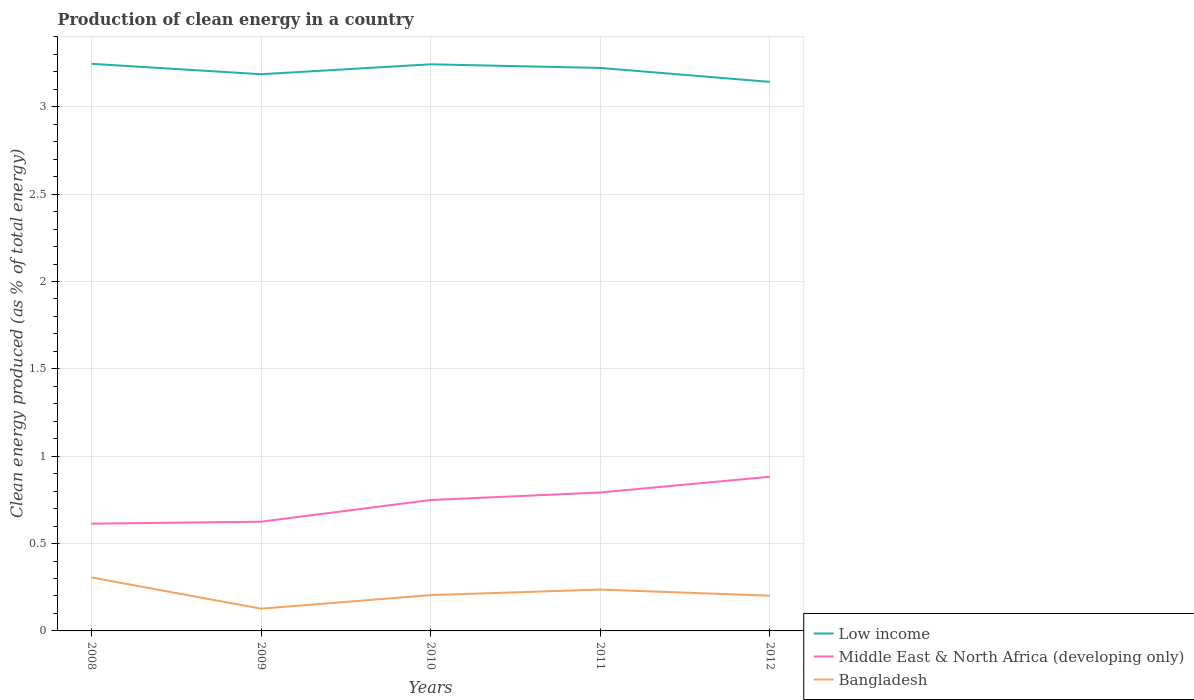Does the line corresponding to Bangladesh intersect with the line corresponding to Low income?
Offer a terse response. No. Is the number of lines equal to the number of legend labels?
Ensure brevity in your answer.  Yes. Across all years, what is the maximum percentage of clean energy produced in Bangladesh?
Your answer should be very brief. 0.13. What is the total percentage of clean energy produced in Bangladesh in the graph?
Your response must be concise. 0.1. What is the difference between the highest and the second highest percentage of clean energy produced in Middle East & North Africa (developing only)?
Your response must be concise. 0.27. What is the difference between the highest and the lowest percentage of clean energy produced in Bangladesh?
Offer a very short reply. 2. What is the difference between two consecutive major ticks on the Y-axis?
Offer a terse response. 0.5. Are the values on the major ticks of Y-axis written in scientific E-notation?
Provide a short and direct response. No. Does the graph contain grids?
Give a very brief answer. Yes. Where does the legend appear in the graph?
Keep it short and to the point. Bottom right. How many legend labels are there?
Provide a succinct answer. 3. How are the legend labels stacked?
Make the answer very short. Vertical. What is the title of the graph?
Give a very brief answer. Production of clean energy in a country. What is the label or title of the X-axis?
Offer a terse response. Years. What is the label or title of the Y-axis?
Your answer should be very brief. Clean energy produced (as % of total energy). What is the Clean energy produced (as % of total energy) of Low income in 2008?
Offer a very short reply. 3.25. What is the Clean energy produced (as % of total energy) in Middle East & North Africa (developing only) in 2008?
Make the answer very short. 0.61. What is the Clean energy produced (as % of total energy) of Bangladesh in 2008?
Offer a terse response. 0.31. What is the Clean energy produced (as % of total energy) of Low income in 2009?
Your answer should be very brief. 3.19. What is the Clean energy produced (as % of total energy) in Middle East & North Africa (developing only) in 2009?
Offer a terse response. 0.63. What is the Clean energy produced (as % of total energy) in Bangladesh in 2009?
Your answer should be very brief. 0.13. What is the Clean energy produced (as % of total energy) in Low income in 2010?
Make the answer very short. 3.24. What is the Clean energy produced (as % of total energy) of Middle East & North Africa (developing only) in 2010?
Offer a very short reply. 0.75. What is the Clean energy produced (as % of total energy) of Bangladesh in 2010?
Provide a short and direct response. 0.2. What is the Clean energy produced (as % of total energy) in Low income in 2011?
Ensure brevity in your answer.  3.22. What is the Clean energy produced (as % of total energy) in Middle East & North Africa (developing only) in 2011?
Offer a very short reply. 0.79. What is the Clean energy produced (as % of total energy) of Bangladesh in 2011?
Keep it short and to the point. 0.24. What is the Clean energy produced (as % of total energy) in Low income in 2012?
Offer a very short reply. 3.14. What is the Clean energy produced (as % of total energy) of Middle East & North Africa (developing only) in 2012?
Give a very brief answer. 0.88. What is the Clean energy produced (as % of total energy) of Bangladesh in 2012?
Ensure brevity in your answer.  0.2. Across all years, what is the maximum Clean energy produced (as % of total energy) of Low income?
Provide a short and direct response. 3.25. Across all years, what is the maximum Clean energy produced (as % of total energy) of Middle East & North Africa (developing only)?
Your response must be concise. 0.88. Across all years, what is the maximum Clean energy produced (as % of total energy) of Bangladesh?
Provide a succinct answer. 0.31. Across all years, what is the minimum Clean energy produced (as % of total energy) of Low income?
Make the answer very short. 3.14. Across all years, what is the minimum Clean energy produced (as % of total energy) in Middle East & North Africa (developing only)?
Make the answer very short. 0.61. Across all years, what is the minimum Clean energy produced (as % of total energy) in Bangladesh?
Give a very brief answer. 0.13. What is the total Clean energy produced (as % of total energy) in Low income in the graph?
Keep it short and to the point. 16.04. What is the total Clean energy produced (as % of total energy) of Middle East & North Africa (developing only) in the graph?
Give a very brief answer. 3.66. What is the total Clean energy produced (as % of total energy) in Bangladesh in the graph?
Your answer should be compact. 1.08. What is the difference between the Clean energy produced (as % of total energy) of Low income in 2008 and that in 2009?
Your response must be concise. 0.06. What is the difference between the Clean energy produced (as % of total energy) of Middle East & North Africa (developing only) in 2008 and that in 2009?
Make the answer very short. -0.01. What is the difference between the Clean energy produced (as % of total energy) of Bangladesh in 2008 and that in 2009?
Your response must be concise. 0.18. What is the difference between the Clean energy produced (as % of total energy) of Low income in 2008 and that in 2010?
Ensure brevity in your answer.  0. What is the difference between the Clean energy produced (as % of total energy) of Middle East & North Africa (developing only) in 2008 and that in 2010?
Make the answer very short. -0.14. What is the difference between the Clean energy produced (as % of total energy) in Bangladesh in 2008 and that in 2010?
Your response must be concise. 0.1. What is the difference between the Clean energy produced (as % of total energy) in Low income in 2008 and that in 2011?
Keep it short and to the point. 0.02. What is the difference between the Clean energy produced (as % of total energy) of Middle East & North Africa (developing only) in 2008 and that in 2011?
Your response must be concise. -0.18. What is the difference between the Clean energy produced (as % of total energy) of Bangladesh in 2008 and that in 2011?
Provide a short and direct response. 0.07. What is the difference between the Clean energy produced (as % of total energy) of Low income in 2008 and that in 2012?
Ensure brevity in your answer.  0.1. What is the difference between the Clean energy produced (as % of total energy) in Middle East & North Africa (developing only) in 2008 and that in 2012?
Provide a short and direct response. -0.27. What is the difference between the Clean energy produced (as % of total energy) of Bangladesh in 2008 and that in 2012?
Offer a terse response. 0.1. What is the difference between the Clean energy produced (as % of total energy) in Low income in 2009 and that in 2010?
Your response must be concise. -0.06. What is the difference between the Clean energy produced (as % of total energy) of Middle East & North Africa (developing only) in 2009 and that in 2010?
Your answer should be compact. -0.12. What is the difference between the Clean energy produced (as % of total energy) of Bangladesh in 2009 and that in 2010?
Ensure brevity in your answer.  -0.08. What is the difference between the Clean energy produced (as % of total energy) of Low income in 2009 and that in 2011?
Your answer should be compact. -0.04. What is the difference between the Clean energy produced (as % of total energy) in Middle East & North Africa (developing only) in 2009 and that in 2011?
Offer a terse response. -0.17. What is the difference between the Clean energy produced (as % of total energy) in Bangladesh in 2009 and that in 2011?
Provide a succinct answer. -0.11. What is the difference between the Clean energy produced (as % of total energy) of Low income in 2009 and that in 2012?
Keep it short and to the point. 0.04. What is the difference between the Clean energy produced (as % of total energy) of Middle East & North Africa (developing only) in 2009 and that in 2012?
Ensure brevity in your answer.  -0.26. What is the difference between the Clean energy produced (as % of total energy) in Bangladesh in 2009 and that in 2012?
Your answer should be very brief. -0.07. What is the difference between the Clean energy produced (as % of total energy) in Low income in 2010 and that in 2011?
Provide a short and direct response. 0.02. What is the difference between the Clean energy produced (as % of total energy) of Middle East & North Africa (developing only) in 2010 and that in 2011?
Offer a very short reply. -0.04. What is the difference between the Clean energy produced (as % of total energy) of Bangladesh in 2010 and that in 2011?
Ensure brevity in your answer.  -0.03. What is the difference between the Clean energy produced (as % of total energy) in Low income in 2010 and that in 2012?
Keep it short and to the point. 0.1. What is the difference between the Clean energy produced (as % of total energy) in Middle East & North Africa (developing only) in 2010 and that in 2012?
Give a very brief answer. -0.13. What is the difference between the Clean energy produced (as % of total energy) of Bangladesh in 2010 and that in 2012?
Offer a very short reply. 0. What is the difference between the Clean energy produced (as % of total energy) in Low income in 2011 and that in 2012?
Make the answer very short. 0.08. What is the difference between the Clean energy produced (as % of total energy) in Middle East & North Africa (developing only) in 2011 and that in 2012?
Offer a terse response. -0.09. What is the difference between the Clean energy produced (as % of total energy) in Bangladesh in 2011 and that in 2012?
Offer a very short reply. 0.04. What is the difference between the Clean energy produced (as % of total energy) of Low income in 2008 and the Clean energy produced (as % of total energy) of Middle East & North Africa (developing only) in 2009?
Provide a short and direct response. 2.62. What is the difference between the Clean energy produced (as % of total energy) in Low income in 2008 and the Clean energy produced (as % of total energy) in Bangladesh in 2009?
Offer a terse response. 3.12. What is the difference between the Clean energy produced (as % of total energy) of Middle East & North Africa (developing only) in 2008 and the Clean energy produced (as % of total energy) of Bangladesh in 2009?
Keep it short and to the point. 0.49. What is the difference between the Clean energy produced (as % of total energy) of Low income in 2008 and the Clean energy produced (as % of total energy) of Middle East & North Africa (developing only) in 2010?
Offer a terse response. 2.5. What is the difference between the Clean energy produced (as % of total energy) in Low income in 2008 and the Clean energy produced (as % of total energy) in Bangladesh in 2010?
Offer a very short reply. 3.04. What is the difference between the Clean energy produced (as % of total energy) in Middle East & North Africa (developing only) in 2008 and the Clean energy produced (as % of total energy) in Bangladesh in 2010?
Ensure brevity in your answer.  0.41. What is the difference between the Clean energy produced (as % of total energy) in Low income in 2008 and the Clean energy produced (as % of total energy) in Middle East & North Africa (developing only) in 2011?
Make the answer very short. 2.45. What is the difference between the Clean energy produced (as % of total energy) in Low income in 2008 and the Clean energy produced (as % of total energy) in Bangladesh in 2011?
Provide a succinct answer. 3.01. What is the difference between the Clean energy produced (as % of total energy) of Middle East & North Africa (developing only) in 2008 and the Clean energy produced (as % of total energy) of Bangladesh in 2011?
Your answer should be very brief. 0.38. What is the difference between the Clean energy produced (as % of total energy) in Low income in 2008 and the Clean energy produced (as % of total energy) in Middle East & North Africa (developing only) in 2012?
Make the answer very short. 2.36. What is the difference between the Clean energy produced (as % of total energy) in Low income in 2008 and the Clean energy produced (as % of total energy) in Bangladesh in 2012?
Keep it short and to the point. 3.04. What is the difference between the Clean energy produced (as % of total energy) of Middle East & North Africa (developing only) in 2008 and the Clean energy produced (as % of total energy) of Bangladesh in 2012?
Make the answer very short. 0.41. What is the difference between the Clean energy produced (as % of total energy) in Low income in 2009 and the Clean energy produced (as % of total energy) in Middle East & North Africa (developing only) in 2010?
Keep it short and to the point. 2.44. What is the difference between the Clean energy produced (as % of total energy) of Low income in 2009 and the Clean energy produced (as % of total energy) of Bangladesh in 2010?
Provide a succinct answer. 2.98. What is the difference between the Clean energy produced (as % of total energy) of Middle East & North Africa (developing only) in 2009 and the Clean energy produced (as % of total energy) of Bangladesh in 2010?
Keep it short and to the point. 0.42. What is the difference between the Clean energy produced (as % of total energy) in Low income in 2009 and the Clean energy produced (as % of total energy) in Middle East & North Africa (developing only) in 2011?
Give a very brief answer. 2.39. What is the difference between the Clean energy produced (as % of total energy) in Low income in 2009 and the Clean energy produced (as % of total energy) in Bangladesh in 2011?
Your answer should be very brief. 2.95. What is the difference between the Clean energy produced (as % of total energy) of Middle East & North Africa (developing only) in 2009 and the Clean energy produced (as % of total energy) of Bangladesh in 2011?
Offer a very short reply. 0.39. What is the difference between the Clean energy produced (as % of total energy) in Low income in 2009 and the Clean energy produced (as % of total energy) in Middle East & North Africa (developing only) in 2012?
Offer a very short reply. 2.3. What is the difference between the Clean energy produced (as % of total energy) in Low income in 2009 and the Clean energy produced (as % of total energy) in Bangladesh in 2012?
Offer a terse response. 2.99. What is the difference between the Clean energy produced (as % of total energy) in Middle East & North Africa (developing only) in 2009 and the Clean energy produced (as % of total energy) in Bangladesh in 2012?
Provide a succinct answer. 0.42. What is the difference between the Clean energy produced (as % of total energy) in Low income in 2010 and the Clean energy produced (as % of total energy) in Middle East & North Africa (developing only) in 2011?
Keep it short and to the point. 2.45. What is the difference between the Clean energy produced (as % of total energy) in Low income in 2010 and the Clean energy produced (as % of total energy) in Bangladesh in 2011?
Offer a terse response. 3.01. What is the difference between the Clean energy produced (as % of total energy) of Middle East & North Africa (developing only) in 2010 and the Clean energy produced (as % of total energy) of Bangladesh in 2011?
Provide a short and direct response. 0.51. What is the difference between the Clean energy produced (as % of total energy) in Low income in 2010 and the Clean energy produced (as % of total energy) in Middle East & North Africa (developing only) in 2012?
Make the answer very short. 2.36. What is the difference between the Clean energy produced (as % of total energy) in Low income in 2010 and the Clean energy produced (as % of total energy) in Bangladesh in 2012?
Ensure brevity in your answer.  3.04. What is the difference between the Clean energy produced (as % of total energy) in Middle East & North Africa (developing only) in 2010 and the Clean energy produced (as % of total energy) in Bangladesh in 2012?
Offer a terse response. 0.55. What is the difference between the Clean energy produced (as % of total energy) of Low income in 2011 and the Clean energy produced (as % of total energy) of Middle East & North Africa (developing only) in 2012?
Provide a short and direct response. 2.34. What is the difference between the Clean energy produced (as % of total energy) in Low income in 2011 and the Clean energy produced (as % of total energy) in Bangladesh in 2012?
Ensure brevity in your answer.  3.02. What is the difference between the Clean energy produced (as % of total energy) of Middle East & North Africa (developing only) in 2011 and the Clean energy produced (as % of total energy) of Bangladesh in 2012?
Your answer should be compact. 0.59. What is the average Clean energy produced (as % of total energy) in Low income per year?
Your answer should be compact. 3.21. What is the average Clean energy produced (as % of total energy) in Middle East & North Africa (developing only) per year?
Your response must be concise. 0.73. What is the average Clean energy produced (as % of total energy) of Bangladesh per year?
Give a very brief answer. 0.22. In the year 2008, what is the difference between the Clean energy produced (as % of total energy) in Low income and Clean energy produced (as % of total energy) in Middle East & North Africa (developing only)?
Your answer should be compact. 2.63. In the year 2008, what is the difference between the Clean energy produced (as % of total energy) in Low income and Clean energy produced (as % of total energy) in Bangladesh?
Provide a succinct answer. 2.94. In the year 2008, what is the difference between the Clean energy produced (as % of total energy) of Middle East & North Africa (developing only) and Clean energy produced (as % of total energy) of Bangladesh?
Keep it short and to the point. 0.31. In the year 2009, what is the difference between the Clean energy produced (as % of total energy) in Low income and Clean energy produced (as % of total energy) in Middle East & North Africa (developing only)?
Offer a very short reply. 2.56. In the year 2009, what is the difference between the Clean energy produced (as % of total energy) of Low income and Clean energy produced (as % of total energy) of Bangladesh?
Offer a very short reply. 3.06. In the year 2009, what is the difference between the Clean energy produced (as % of total energy) of Middle East & North Africa (developing only) and Clean energy produced (as % of total energy) of Bangladesh?
Make the answer very short. 0.5. In the year 2010, what is the difference between the Clean energy produced (as % of total energy) in Low income and Clean energy produced (as % of total energy) in Middle East & North Africa (developing only)?
Make the answer very short. 2.49. In the year 2010, what is the difference between the Clean energy produced (as % of total energy) of Low income and Clean energy produced (as % of total energy) of Bangladesh?
Give a very brief answer. 3.04. In the year 2010, what is the difference between the Clean energy produced (as % of total energy) in Middle East & North Africa (developing only) and Clean energy produced (as % of total energy) in Bangladesh?
Your response must be concise. 0.54. In the year 2011, what is the difference between the Clean energy produced (as % of total energy) in Low income and Clean energy produced (as % of total energy) in Middle East & North Africa (developing only)?
Your answer should be very brief. 2.43. In the year 2011, what is the difference between the Clean energy produced (as % of total energy) in Low income and Clean energy produced (as % of total energy) in Bangladesh?
Your answer should be very brief. 2.99. In the year 2011, what is the difference between the Clean energy produced (as % of total energy) of Middle East & North Africa (developing only) and Clean energy produced (as % of total energy) of Bangladesh?
Your response must be concise. 0.56. In the year 2012, what is the difference between the Clean energy produced (as % of total energy) of Low income and Clean energy produced (as % of total energy) of Middle East & North Africa (developing only)?
Offer a very short reply. 2.26. In the year 2012, what is the difference between the Clean energy produced (as % of total energy) of Low income and Clean energy produced (as % of total energy) of Bangladesh?
Ensure brevity in your answer.  2.94. In the year 2012, what is the difference between the Clean energy produced (as % of total energy) of Middle East & North Africa (developing only) and Clean energy produced (as % of total energy) of Bangladesh?
Provide a succinct answer. 0.68. What is the ratio of the Clean energy produced (as % of total energy) of Low income in 2008 to that in 2009?
Ensure brevity in your answer.  1.02. What is the ratio of the Clean energy produced (as % of total energy) of Middle East & North Africa (developing only) in 2008 to that in 2009?
Provide a succinct answer. 0.98. What is the ratio of the Clean energy produced (as % of total energy) of Bangladesh in 2008 to that in 2009?
Keep it short and to the point. 2.4. What is the ratio of the Clean energy produced (as % of total energy) of Middle East & North Africa (developing only) in 2008 to that in 2010?
Make the answer very short. 0.82. What is the ratio of the Clean energy produced (as % of total energy) in Bangladesh in 2008 to that in 2010?
Your answer should be very brief. 1.49. What is the ratio of the Clean energy produced (as % of total energy) of Low income in 2008 to that in 2011?
Offer a very short reply. 1.01. What is the ratio of the Clean energy produced (as % of total energy) of Middle East & North Africa (developing only) in 2008 to that in 2011?
Your answer should be very brief. 0.77. What is the ratio of the Clean energy produced (as % of total energy) in Bangladesh in 2008 to that in 2011?
Your response must be concise. 1.29. What is the ratio of the Clean energy produced (as % of total energy) in Low income in 2008 to that in 2012?
Offer a terse response. 1.03. What is the ratio of the Clean energy produced (as % of total energy) in Middle East & North Africa (developing only) in 2008 to that in 2012?
Your response must be concise. 0.7. What is the ratio of the Clean energy produced (as % of total energy) in Bangladesh in 2008 to that in 2012?
Your response must be concise. 1.52. What is the ratio of the Clean energy produced (as % of total energy) of Low income in 2009 to that in 2010?
Your answer should be compact. 0.98. What is the ratio of the Clean energy produced (as % of total energy) in Middle East & North Africa (developing only) in 2009 to that in 2010?
Offer a terse response. 0.83. What is the ratio of the Clean energy produced (as % of total energy) of Bangladesh in 2009 to that in 2010?
Offer a very short reply. 0.62. What is the ratio of the Clean energy produced (as % of total energy) of Middle East & North Africa (developing only) in 2009 to that in 2011?
Your answer should be very brief. 0.79. What is the ratio of the Clean energy produced (as % of total energy) of Bangladesh in 2009 to that in 2011?
Keep it short and to the point. 0.54. What is the ratio of the Clean energy produced (as % of total energy) in Low income in 2009 to that in 2012?
Provide a succinct answer. 1.01. What is the ratio of the Clean energy produced (as % of total energy) in Middle East & North Africa (developing only) in 2009 to that in 2012?
Provide a succinct answer. 0.71. What is the ratio of the Clean energy produced (as % of total energy) in Bangladesh in 2009 to that in 2012?
Give a very brief answer. 0.63. What is the ratio of the Clean energy produced (as % of total energy) in Low income in 2010 to that in 2011?
Provide a succinct answer. 1.01. What is the ratio of the Clean energy produced (as % of total energy) in Middle East & North Africa (developing only) in 2010 to that in 2011?
Make the answer very short. 0.95. What is the ratio of the Clean energy produced (as % of total energy) of Bangladesh in 2010 to that in 2011?
Your answer should be compact. 0.87. What is the ratio of the Clean energy produced (as % of total energy) of Low income in 2010 to that in 2012?
Keep it short and to the point. 1.03. What is the ratio of the Clean energy produced (as % of total energy) in Middle East & North Africa (developing only) in 2010 to that in 2012?
Provide a succinct answer. 0.85. What is the ratio of the Clean energy produced (as % of total energy) in Bangladesh in 2010 to that in 2012?
Your answer should be compact. 1.02. What is the ratio of the Clean energy produced (as % of total energy) in Low income in 2011 to that in 2012?
Offer a terse response. 1.03. What is the ratio of the Clean energy produced (as % of total energy) in Middle East & North Africa (developing only) in 2011 to that in 2012?
Your answer should be compact. 0.9. What is the ratio of the Clean energy produced (as % of total energy) of Bangladesh in 2011 to that in 2012?
Your answer should be very brief. 1.17. What is the difference between the highest and the second highest Clean energy produced (as % of total energy) in Low income?
Keep it short and to the point. 0. What is the difference between the highest and the second highest Clean energy produced (as % of total energy) of Middle East & North Africa (developing only)?
Make the answer very short. 0.09. What is the difference between the highest and the second highest Clean energy produced (as % of total energy) in Bangladesh?
Your answer should be very brief. 0.07. What is the difference between the highest and the lowest Clean energy produced (as % of total energy) of Low income?
Ensure brevity in your answer.  0.1. What is the difference between the highest and the lowest Clean energy produced (as % of total energy) of Middle East & North Africa (developing only)?
Provide a succinct answer. 0.27. What is the difference between the highest and the lowest Clean energy produced (as % of total energy) of Bangladesh?
Keep it short and to the point. 0.18. 